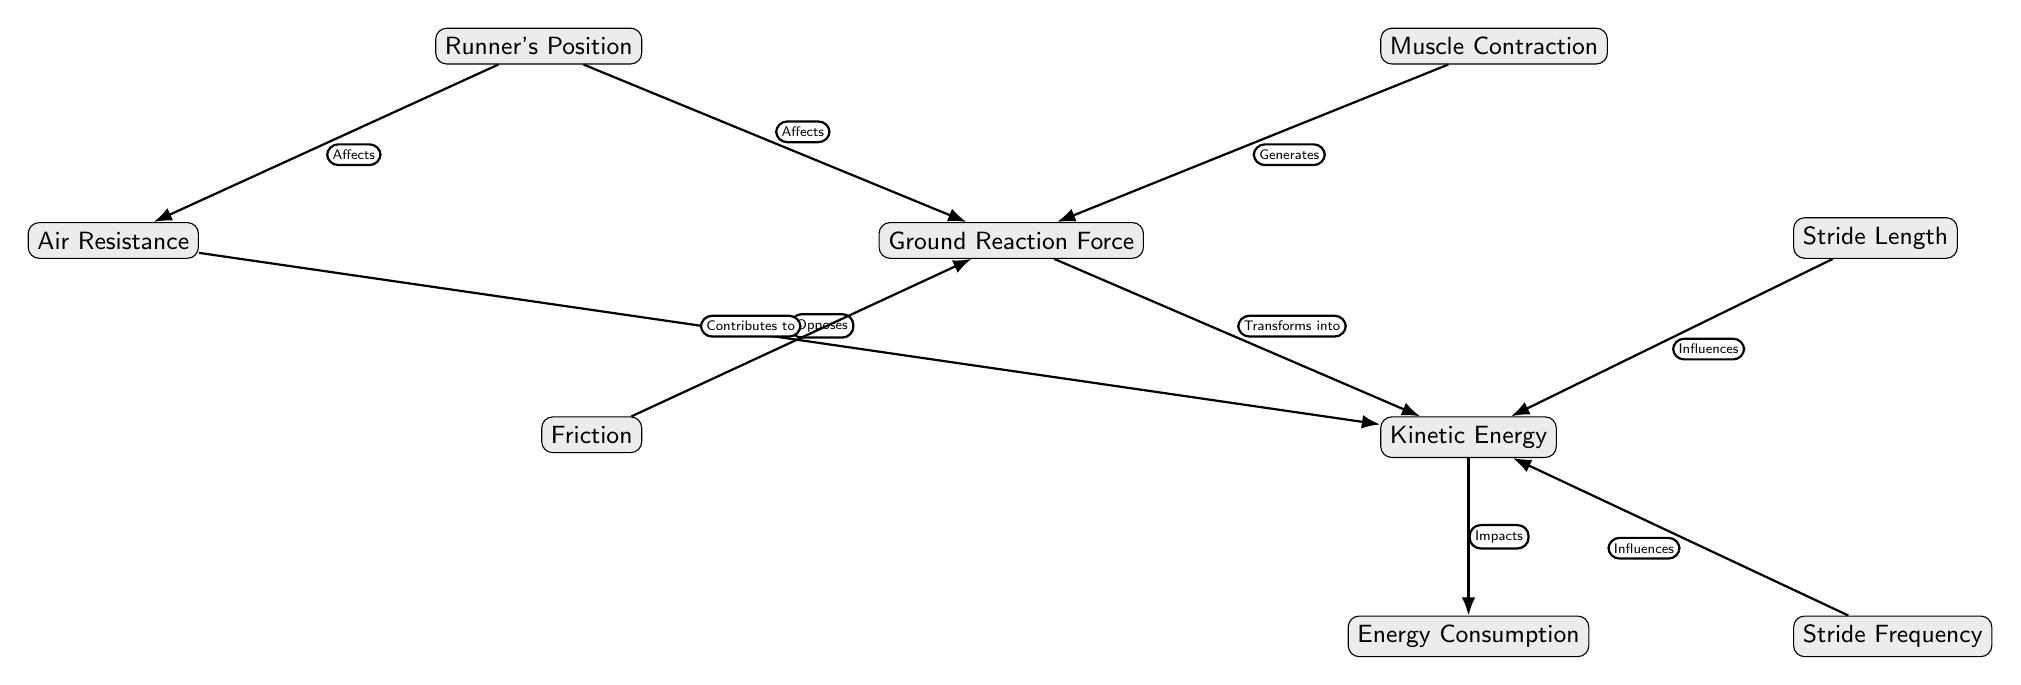What are the nodes in the diagram? The nodes in the diagram are: Runner's Position, Ground Reaction Force, Muscle Contraction, Air Resistance, Kinetic Energy, Friction, Stride Length, Stride Frequency, and Energy Consumption.
Answer: Runner's Position, Ground Reaction Force, Muscle Contraction, Air Resistance, Kinetic Energy, Friction, Stride Length, Stride Frequency, Energy Consumption How many edges are in the diagram? There are eight edges in the diagram connecting the different nodes, indicating the relationships between them.
Answer: 8 What does the Ground Reaction Force do? The Ground Reaction Force is affected by the Runner's Position and generates from Muscle Contraction, contributing to Kinetic Energy and influenced by Friction.
Answer: Affects, Generates, Contributes to Which node directly influences Kinetic Energy? Stride Length and Stride Frequency directly influence Kinetic Energy, as indicated by their connections in the diagram.
Answer: Stride Length, Stride Frequency What opposes Kinetic Energy according to the diagram? Air Resistance opposes Kinetic Energy, indicating it acts against the energy generated by the runner.
Answer: Air Resistance What is affected by the Runner's Position? The Runner's Position affects both Ground Reaction Force and Air Resistance, showing how the position impacts these forces during sprinting.
Answer: Ground Reaction Force, Air Resistance What impacts Energy Consumption? Kinetic Energy impacts Energy Consumption, suggesting that the amount of kinetic energy generated influences how much energy a runner uses.
Answer: Kinetic Energy Explain the relationship between Muscle Contraction and Ground Reaction Force. Muscle Contraction generates the Ground Reaction Force, indicating that the strength and timing of muscle movements directly contribute to the force exerted against the ground.
Answer: Generates Which relationship in the diagram shows the influence of stride components on energy? The relationship indicates that both Stride Length and Stride Frequency influence Kinetic Energy, which in turn impacts Energy Consumption, showcasing how these components are crucial for a runner’s efficiency.
Answer: Influences What role does Friction play in the context of the diagram? Friction contributes to the Ground Reaction Force, suggesting its importance in providing the necessary grip for effective propulsion while running.
Answer: Contributes to 